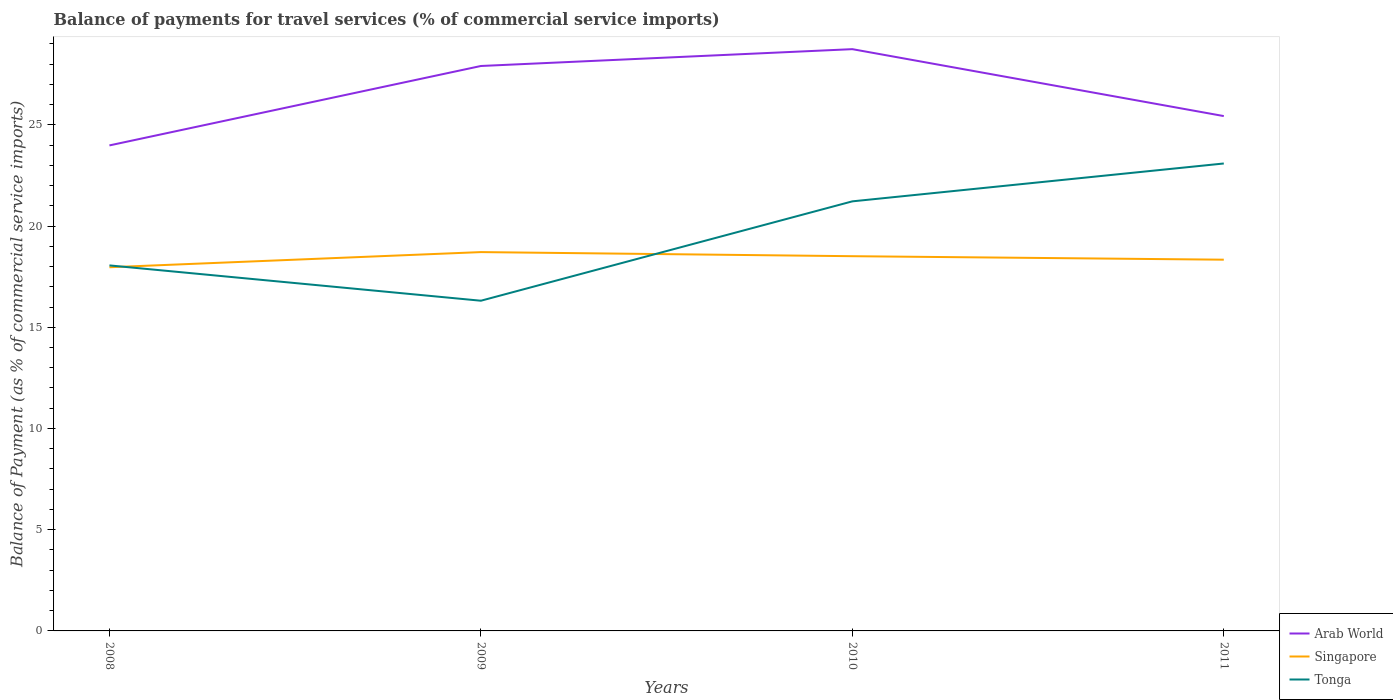How many different coloured lines are there?
Your answer should be compact. 3. Across all years, what is the maximum balance of payments for travel services in Tonga?
Ensure brevity in your answer.  16.31. What is the total balance of payments for travel services in Arab World in the graph?
Give a very brief answer. -1.45. What is the difference between the highest and the second highest balance of payments for travel services in Singapore?
Keep it short and to the point. 0.75. What is the difference between the highest and the lowest balance of payments for travel services in Tonga?
Ensure brevity in your answer.  2. How many lines are there?
Provide a succinct answer. 3. What is the difference between two consecutive major ticks on the Y-axis?
Your answer should be compact. 5. Are the values on the major ticks of Y-axis written in scientific E-notation?
Your answer should be compact. No. How are the legend labels stacked?
Offer a very short reply. Vertical. What is the title of the graph?
Your answer should be very brief. Balance of payments for travel services (% of commercial service imports). What is the label or title of the Y-axis?
Your response must be concise. Balance of Payment (as % of commercial service imports). What is the Balance of Payment (as % of commercial service imports) of Arab World in 2008?
Your answer should be very brief. 23.98. What is the Balance of Payment (as % of commercial service imports) in Singapore in 2008?
Ensure brevity in your answer.  17.96. What is the Balance of Payment (as % of commercial service imports) of Tonga in 2008?
Make the answer very short. 18.06. What is the Balance of Payment (as % of commercial service imports) in Arab World in 2009?
Your response must be concise. 27.91. What is the Balance of Payment (as % of commercial service imports) in Singapore in 2009?
Make the answer very short. 18.71. What is the Balance of Payment (as % of commercial service imports) in Tonga in 2009?
Your answer should be compact. 16.31. What is the Balance of Payment (as % of commercial service imports) of Arab World in 2010?
Provide a short and direct response. 28.74. What is the Balance of Payment (as % of commercial service imports) of Singapore in 2010?
Your answer should be compact. 18.51. What is the Balance of Payment (as % of commercial service imports) of Tonga in 2010?
Your answer should be very brief. 21.22. What is the Balance of Payment (as % of commercial service imports) in Arab World in 2011?
Your answer should be compact. 25.43. What is the Balance of Payment (as % of commercial service imports) in Singapore in 2011?
Ensure brevity in your answer.  18.34. What is the Balance of Payment (as % of commercial service imports) in Tonga in 2011?
Your response must be concise. 23.09. Across all years, what is the maximum Balance of Payment (as % of commercial service imports) in Arab World?
Your response must be concise. 28.74. Across all years, what is the maximum Balance of Payment (as % of commercial service imports) of Singapore?
Provide a succinct answer. 18.71. Across all years, what is the maximum Balance of Payment (as % of commercial service imports) in Tonga?
Keep it short and to the point. 23.09. Across all years, what is the minimum Balance of Payment (as % of commercial service imports) of Arab World?
Provide a short and direct response. 23.98. Across all years, what is the minimum Balance of Payment (as % of commercial service imports) in Singapore?
Ensure brevity in your answer.  17.96. Across all years, what is the minimum Balance of Payment (as % of commercial service imports) in Tonga?
Make the answer very short. 16.31. What is the total Balance of Payment (as % of commercial service imports) of Arab World in the graph?
Your answer should be very brief. 106.06. What is the total Balance of Payment (as % of commercial service imports) in Singapore in the graph?
Your answer should be very brief. 73.53. What is the total Balance of Payment (as % of commercial service imports) in Tonga in the graph?
Provide a short and direct response. 78.68. What is the difference between the Balance of Payment (as % of commercial service imports) in Arab World in 2008 and that in 2009?
Your response must be concise. -3.92. What is the difference between the Balance of Payment (as % of commercial service imports) of Singapore in 2008 and that in 2009?
Your answer should be compact. -0.75. What is the difference between the Balance of Payment (as % of commercial service imports) of Tonga in 2008 and that in 2009?
Offer a terse response. 1.74. What is the difference between the Balance of Payment (as % of commercial service imports) of Arab World in 2008 and that in 2010?
Offer a very short reply. -4.76. What is the difference between the Balance of Payment (as % of commercial service imports) in Singapore in 2008 and that in 2010?
Ensure brevity in your answer.  -0.55. What is the difference between the Balance of Payment (as % of commercial service imports) of Tonga in 2008 and that in 2010?
Give a very brief answer. -3.16. What is the difference between the Balance of Payment (as % of commercial service imports) of Arab World in 2008 and that in 2011?
Offer a terse response. -1.45. What is the difference between the Balance of Payment (as % of commercial service imports) of Singapore in 2008 and that in 2011?
Your response must be concise. -0.37. What is the difference between the Balance of Payment (as % of commercial service imports) of Tonga in 2008 and that in 2011?
Offer a terse response. -5.03. What is the difference between the Balance of Payment (as % of commercial service imports) in Arab World in 2009 and that in 2010?
Your response must be concise. -0.83. What is the difference between the Balance of Payment (as % of commercial service imports) of Singapore in 2009 and that in 2010?
Make the answer very short. 0.2. What is the difference between the Balance of Payment (as % of commercial service imports) of Tonga in 2009 and that in 2010?
Your response must be concise. -4.91. What is the difference between the Balance of Payment (as % of commercial service imports) in Arab World in 2009 and that in 2011?
Make the answer very short. 2.47. What is the difference between the Balance of Payment (as % of commercial service imports) of Singapore in 2009 and that in 2011?
Keep it short and to the point. 0.37. What is the difference between the Balance of Payment (as % of commercial service imports) of Tonga in 2009 and that in 2011?
Offer a very short reply. -6.78. What is the difference between the Balance of Payment (as % of commercial service imports) in Arab World in 2010 and that in 2011?
Ensure brevity in your answer.  3.31. What is the difference between the Balance of Payment (as % of commercial service imports) in Singapore in 2010 and that in 2011?
Provide a succinct answer. 0.17. What is the difference between the Balance of Payment (as % of commercial service imports) of Tonga in 2010 and that in 2011?
Your answer should be very brief. -1.87. What is the difference between the Balance of Payment (as % of commercial service imports) in Arab World in 2008 and the Balance of Payment (as % of commercial service imports) in Singapore in 2009?
Provide a short and direct response. 5.27. What is the difference between the Balance of Payment (as % of commercial service imports) of Arab World in 2008 and the Balance of Payment (as % of commercial service imports) of Tonga in 2009?
Offer a terse response. 7.67. What is the difference between the Balance of Payment (as % of commercial service imports) of Singapore in 2008 and the Balance of Payment (as % of commercial service imports) of Tonga in 2009?
Offer a terse response. 1.65. What is the difference between the Balance of Payment (as % of commercial service imports) in Arab World in 2008 and the Balance of Payment (as % of commercial service imports) in Singapore in 2010?
Provide a succinct answer. 5.47. What is the difference between the Balance of Payment (as % of commercial service imports) of Arab World in 2008 and the Balance of Payment (as % of commercial service imports) of Tonga in 2010?
Your response must be concise. 2.76. What is the difference between the Balance of Payment (as % of commercial service imports) in Singapore in 2008 and the Balance of Payment (as % of commercial service imports) in Tonga in 2010?
Keep it short and to the point. -3.26. What is the difference between the Balance of Payment (as % of commercial service imports) of Arab World in 2008 and the Balance of Payment (as % of commercial service imports) of Singapore in 2011?
Your answer should be compact. 5.64. What is the difference between the Balance of Payment (as % of commercial service imports) of Arab World in 2008 and the Balance of Payment (as % of commercial service imports) of Tonga in 2011?
Give a very brief answer. 0.89. What is the difference between the Balance of Payment (as % of commercial service imports) in Singapore in 2008 and the Balance of Payment (as % of commercial service imports) in Tonga in 2011?
Give a very brief answer. -5.13. What is the difference between the Balance of Payment (as % of commercial service imports) in Arab World in 2009 and the Balance of Payment (as % of commercial service imports) in Singapore in 2010?
Provide a short and direct response. 9.4. What is the difference between the Balance of Payment (as % of commercial service imports) in Arab World in 2009 and the Balance of Payment (as % of commercial service imports) in Tonga in 2010?
Your answer should be very brief. 6.69. What is the difference between the Balance of Payment (as % of commercial service imports) in Singapore in 2009 and the Balance of Payment (as % of commercial service imports) in Tonga in 2010?
Your answer should be compact. -2.51. What is the difference between the Balance of Payment (as % of commercial service imports) of Arab World in 2009 and the Balance of Payment (as % of commercial service imports) of Singapore in 2011?
Offer a terse response. 9.57. What is the difference between the Balance of Payment (as % of commercial service imports) of Arab World in 2009 and the Balance of Payment (as % of commercial service imports) of Tonga in 2011?
Make the answer very short. 4.82. What is the difference between the Balance of Payment (as % of commercial service imports) of Singapore in 2009 and the Balance of Payment (as % of commercial service imports) of Tonga in 2011?
Provide a succinct answer. -4.38. What is the difference between the Balance of Payment (as % of commercial service imports) in Arab World in 2010 and the Balance of Payment (as % of commercial service imports) in Singapore in 2011?
Offer a very short reply. 10.4. What is the difference between the Balance of Payment (as % of commercial service imports) in Arab World in 2010 and the Balance of Payment (as % of commercial service imports) in Tonga in 2011?
Your answer should be very brief. 5.65. What is the difference between the Balance of Payment (as % of commercial service imports) of Singapore in 2010 and the Balance of Payment (as % of commercial service imports) of Tonga in 2011?
Give a very brief answer. -4.58. What is the average Balance of Payment (as % of commercial service imports) in Arab World per year?
Keep it short and to the point. 26.52. What is the average Balance of Payment (as % of commercial service imports) in Singapore per year?
Your answer should be very brief. 18.38. What is the average Balance of Payment (as % of commercial service imports) of Tonga per year?
Provide a short and direct response. 19.67. In the year 2008, what is the difference between the Balance of Payment (as % of commercial service imports) in Arab World and Balance of Payment (as % of commercial service imports) in Singapore?
Give a very brief answer. 6.02. In the year 2008, what is the difference between the Balance of Payment (as % of commercial service imports) in Arab World and Balance of Payment (as % of commercial service imports) in Tonga?
Give a very brief answer. 5.93. In the year 2008, what is the difference between the Balance of Payment (as % of commercial service imports) in Singapore and Balance of Payment (as % of commercial service imports) in Tonga?
Offer a very short reply. -0.09. In the year 2009, what is the difference between the Balance of Payment (as % of commercial service imports) of Arab World and Balance of Payment (as % of commercial service imports) of Singapore?
Offer a terse response. 9.19. In the year 2009, what is the difference between the Balance of Payment (as % of commercial service imports) of Arab World and Balance of Payment (as % of commercial service imports) of Tonga?
Your response must be concise. 11.6. In the year 2009, what is the difference between the Balance of Payment (as % of commercial service imports) in Singapore and Balance of Payment (as % of commercial service imports) in Tonga?
Make the answer very short. 2.4. In the year 2010, what is the difference between the Balance of Payment (as % of commercial service imports) in Arab World and Balance of Payment (as % of commercial service imports) in Singapore?
Ensure brevity in your answer.  10.23. In the year 2010, what is the difference between the Balance of Payment (as % of commercial service imports) in Arab World and Balance of Payment (as % of commercial service imports) in Tonga?
Keep it short and to the point. 7.52. In the year 2010, what is the difference between the Balance of Payment (as % of commercial service imports) in Singapore and Balance of Payment (as % of commercial service imports) in Tonga?
Make the answer very short. -2.71. In the year 2011, what is the difference between the Balance of Payment (as % of commercial service imports) of Arab World and Balance of Payment (as % of commercial service imports) of Singapore?
Offer a terse response. 7.09. In the year 2011, what is the difference between the Balance of Payment (as % of commercial service imports) of Arab World and Balance of Payment (as % of commercial service imports) of Tonga?
Keep it short and to the point. 2.34. In the year 2011, what is the difference between the Balance of Payment (as % of commercial service imports) of Singapore and Balance of Payment (as % of commercial service imports) of Tonga?
Give a very brief answer. -4.75. What is the ratio of the Balance of Payment (as % of commercial service imports) in Arab World in 2008 to that in 2009?
Ensure brevity in your answer.  0.86. What is the ratio of the Balance of Payment (as % of commercial service imports) of Singapore in 2008 to that in 2009?
Ensure brevity in your answer.  0.96. What is the ratio of the Balance of Payment (as % of commercial service imports) of Tonga in 2008 to that in 2009?
Provide a succinct answer. 1.11. What is the ratio of the Balance of Payment (as % of commercial service imports) of Arab World in 2008 to that in 2010?
Offer a very short reply. 0.83. What is the ratio of the Balance of Payment (as % of commercial service imports) of Singapore in 2008 to that in 2010?
Keep it short and to the point. 0.97. What is the ratio of the Balance of Payment (as % of commercial service imports) of Tonga in 2008 to that in 2010?
Provide a short and direct response. 0.85. What is the ratio of the Balance of Payment (as % of commercial service imports) in Arab World in 2008 to that in 2011?
Your answer should be very brief. 0.94. What is the ratio of the Balance of Payment (as % of commercial service imports) in Singapore in 2008 to that in 2011?
Offer a terse response. 0.98. What is the ratio of the Balance of Payment (as % of commercial service imports) of Tonga in 2008 to that in 2011?
Your answer should be compact. 0.78. What is the ratio of the Balance of Payment (as % of commercial service imports) in Arab World in 2009 to that in 2010?
Offer a terse response. 0.97. What is the ratio of the Balance of Payment (as % of commercial service imports) of Singapore in 2009 to that in 2010?
Ensure brevity in your answer.  1.01. What is the ratio of the Balance of Payment (as % of commercial service imports) in Tonga in 2009 to that in 2010?
Your answer should be compact. 0.77. What is the ratio of the Balance of Payment (as % of commercial service imports) of Arab World in 2009 to that in 2011?
Your answer should be compact. 1.1. What is the ratio of the Balance of Payment (as % of commercial service imports) in Singapore in 2009 to that in 2011?
Keep it short and to the point. 1.02. What is the ratio of the Balance of Payment (as % of commercial service imports) in Tonga in 2009 to that in 2011?
Provide a short and direct response. 0.71. What is the ratio of the Balance of Payment (as % of commercial service imports) in Arab World in 2010 to that in 2011?
Provide a succinct answer. 1.13. What is the ratio of the Balance of Payment (as % of commercial service imports) in Singapore in 2010 to that in 2011?
Provide a succinct answer. 1.01. What is the ratio of the Balance of Payment (as % of commercial service imports) of Tonga in 2010 to that in 2011?
Make the answer very short. 0.92. What is the difference between the highest and the second highest Balance of Payment (as % of commercial service imports) of Arab World?
Offer a very short reply. 0.83. What is the difference between the highest and the second highest Balance of Payment (as % of commercial service imports) of Singapore?
Provide a short and direct response. 0.2. What is the difference between the highest and the second highest Balance of Payment (as % of commercial service imports) in Tonga?
Provide a short and direct response. 1.87. What is the difference between the highest and the lowest Balance of Payment (as % of commercial service imports) in Arab World?
Make the answer very short. 4.76. What is the difference between the highest and the lowest Balance of Payment (as % of commercial service imports) of Singapore?
Keep it short and to the point. 0.75. What is the difference between the highest and the lowest Balance of Payment (as % of commercial service imports) in Tonga?
Provide a succinct answer. 6.78. 